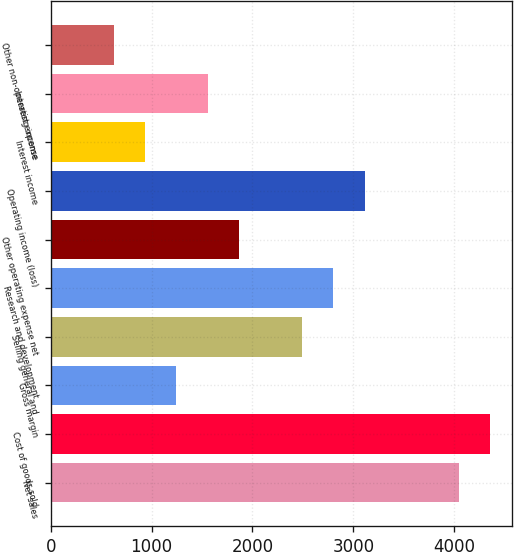Convert chart. <chart><loc_0><loc_0><loc_500><loc_500><bar_chart><fcel>Net sales<fcel>Cost of goods sold<fcel>Gross margin<fcel>Selling general and<fcel>Research and development<fcel>Other operating expense net<fcel>Operating income (loss)<fcel>Interest income<fcel>Interest expense<fcel>Other non-operating income<nl><fcel>4044.98<fcel>4355.97<fcel>1246.07<fcel>2490.03<fcel>2801.02<fcel>1868.05<fcel>3112.01<fcel>935.08<fcel>1557.06<fcel>624.09<nl></chart> 